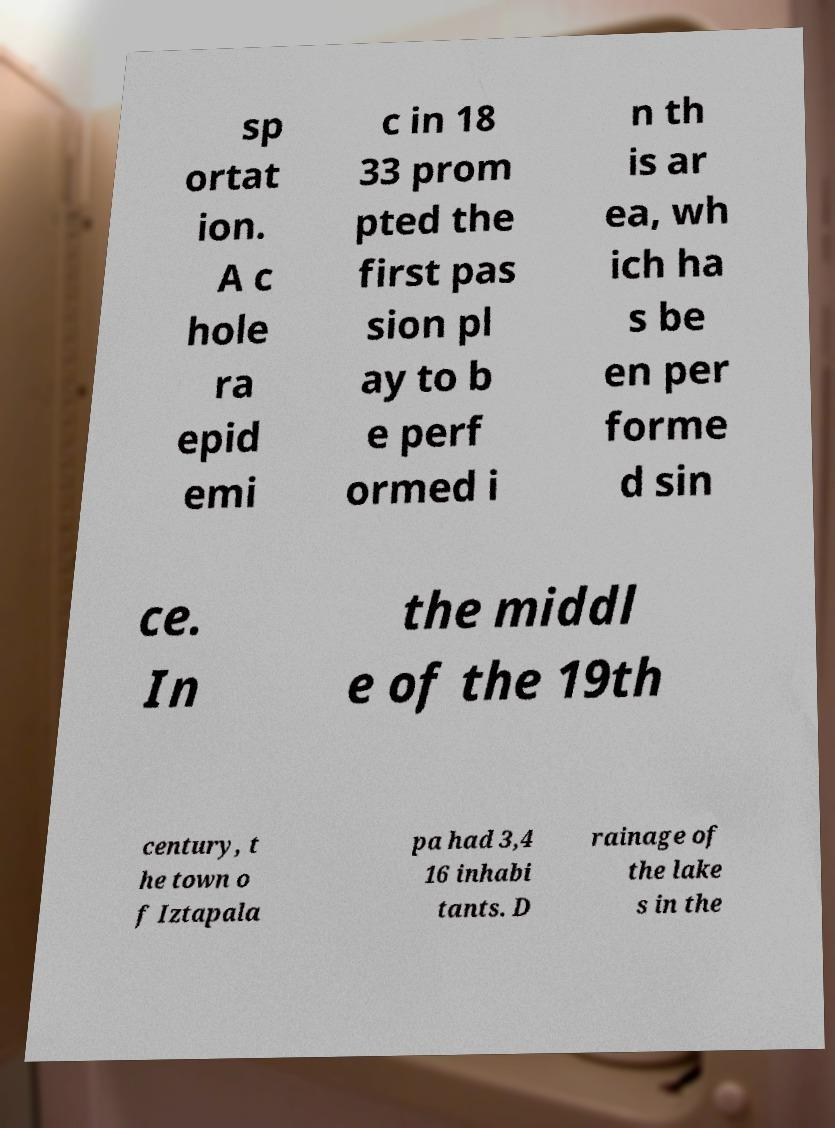What messages or text are displayed in this image? I need them in a readable, typed format. sp ortat ion. A c hole ra epid emi c in 18 33 prom pted the first pas sion pl ay to b e perf ormed i n th is ar ea, wh ich ha s be en per forme d sin ce. In the middl e of the 19th century, t he town o f Iztapala pa had 3,4 16 inhabi tants. D rainage of the lake s in the 